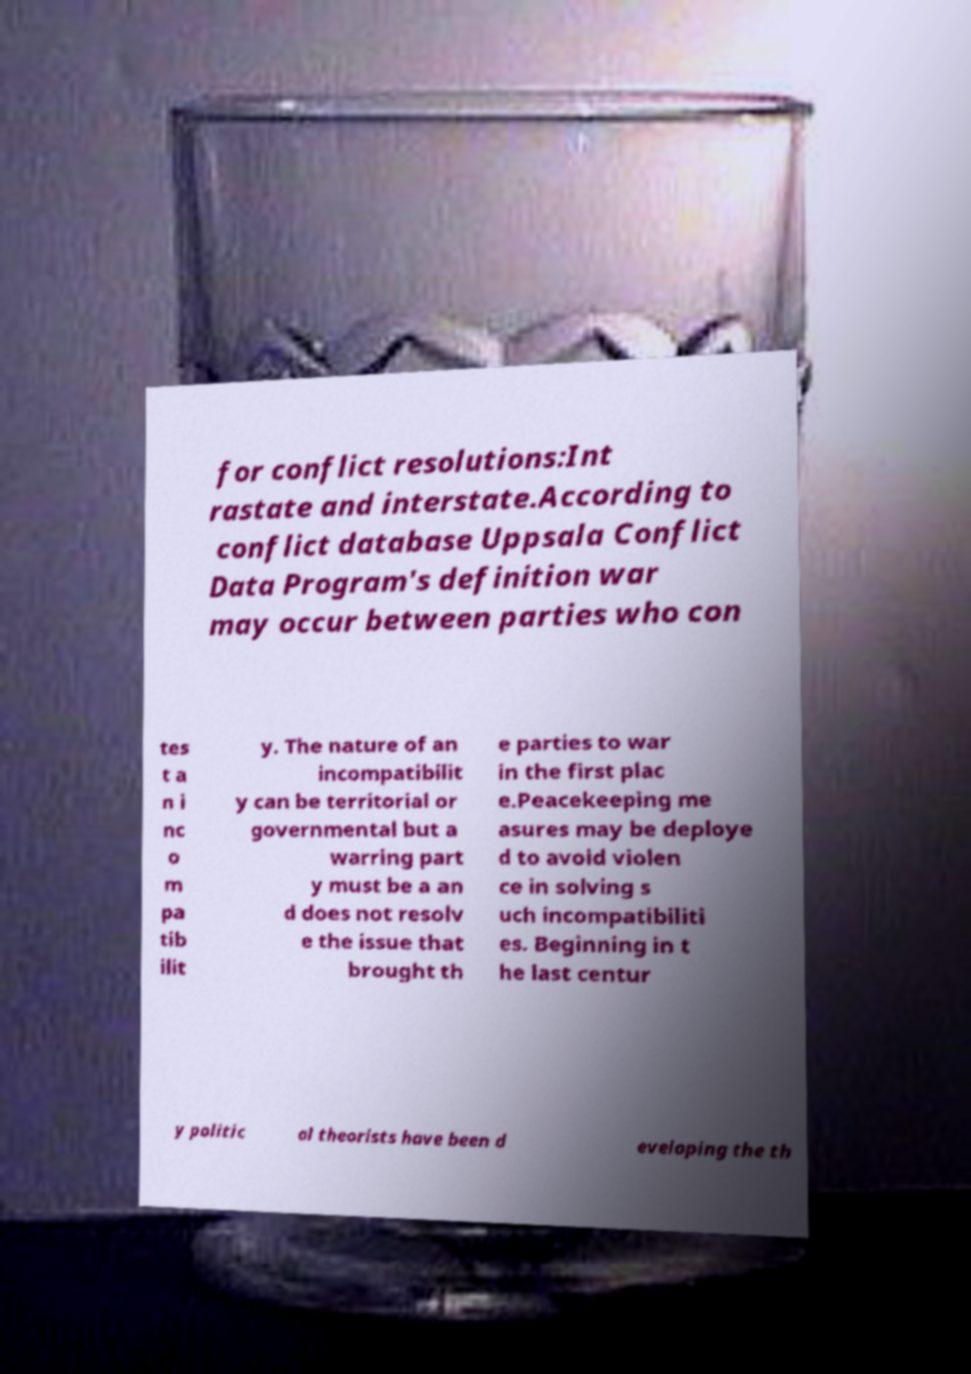Could you assist in decoding the text presented in this image and type it out clearly? for conflict resolutions:Int rastate and interstate.According to conflict database Uppsala Conflict Data Program's definition war may occur between parties who con tes t a n i nc o m pa tib ilit y. The nature of an incompatibilit y can be territorial or governmental but a warring part y must be a an d does not resolv e the issue that brought th e parties to war in the first plac e.Peacekeeping me asures may be deploye d to avoid violen ce in solving s uch incompatibiliti es. Beginning in t he last centur y politic al theorists have been d eveloping the th 